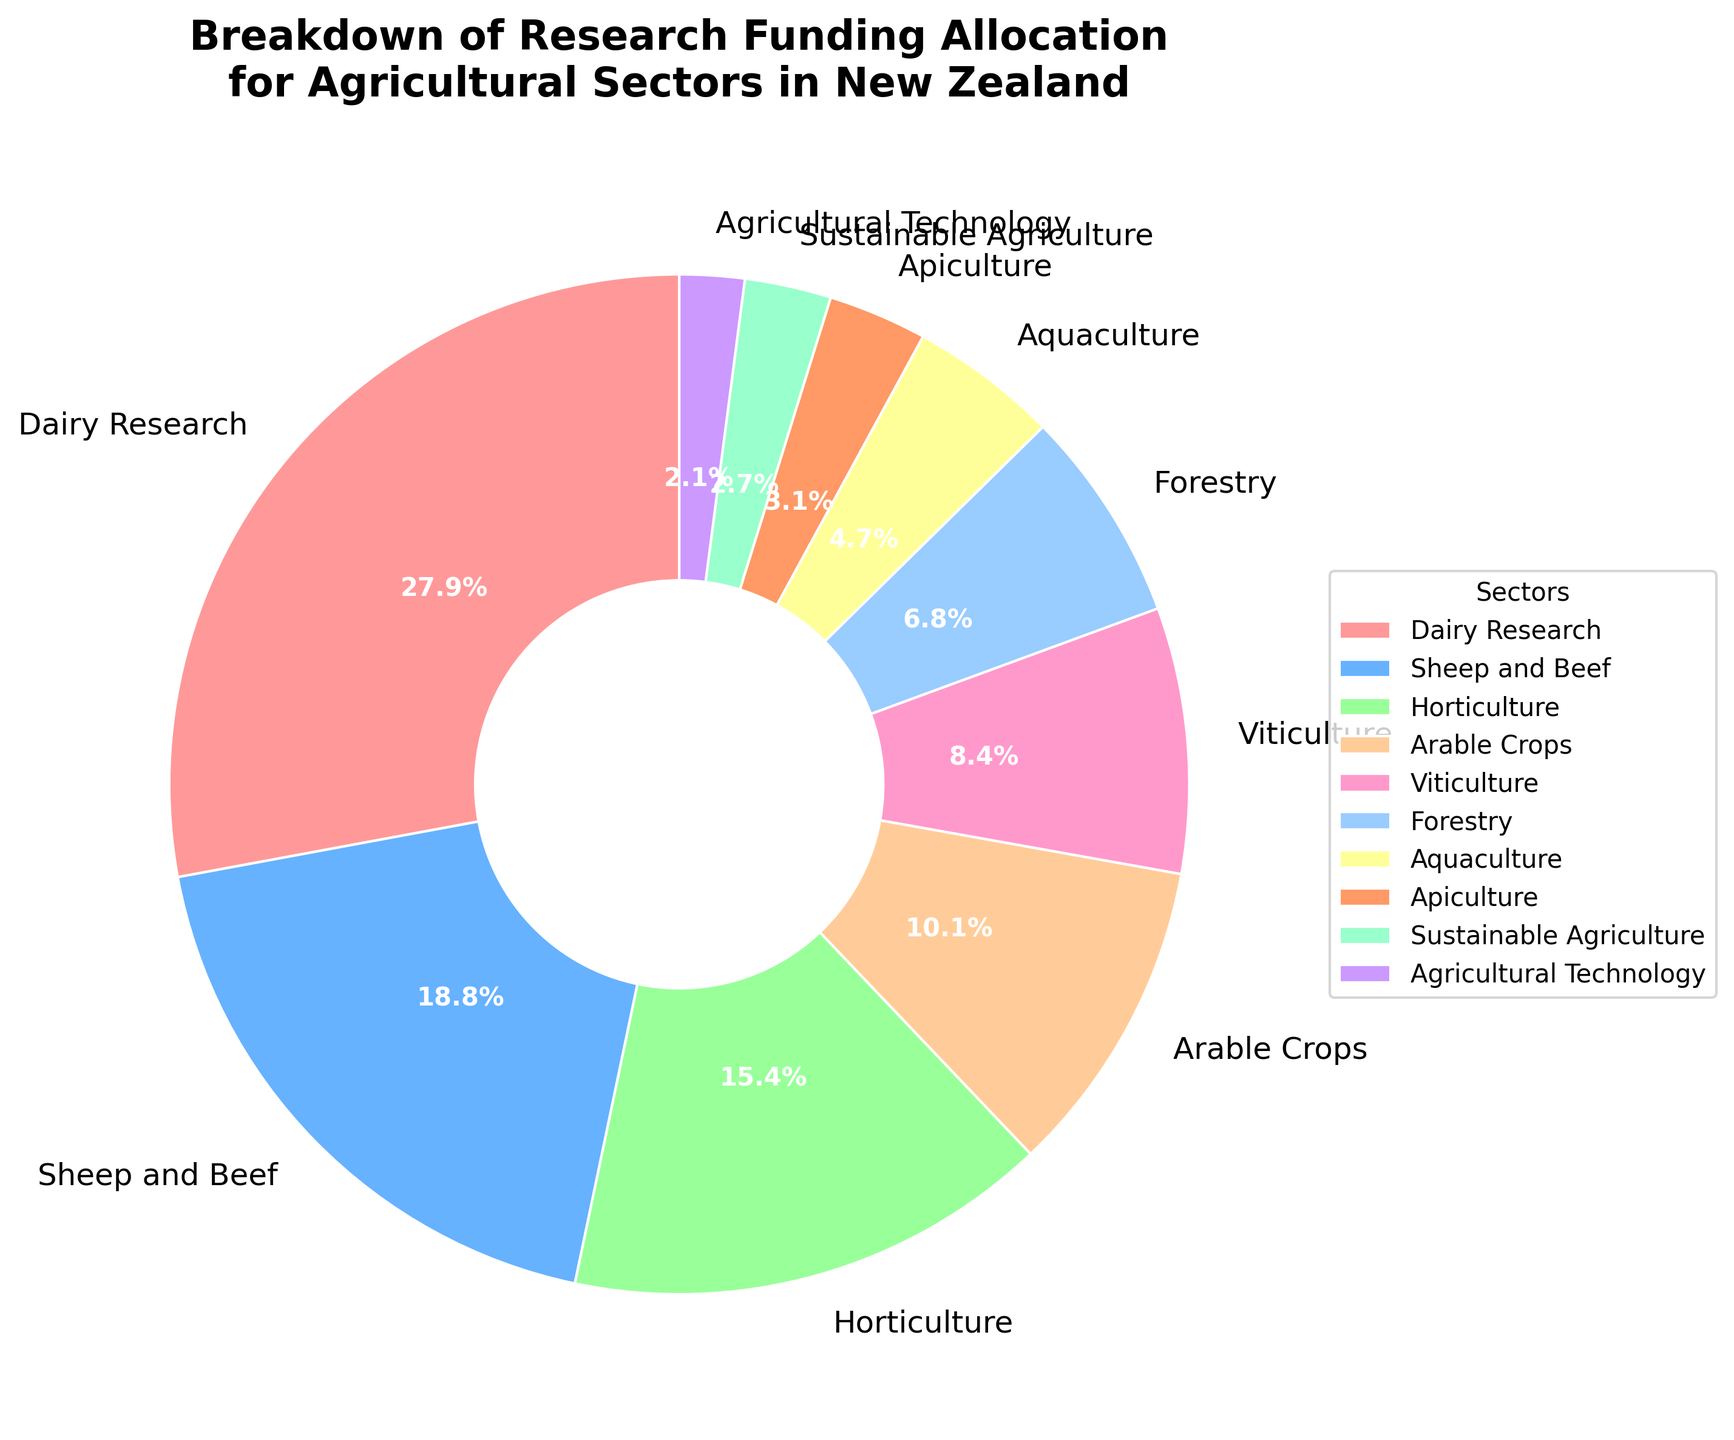What's the sector with the highest funding allocation? Looking at the pie chart, the sector with the largest slice of the pie chart represents the highest funding allocation. In this case, Dairy Research occupies the largest sector in the pie chart.
Answer: Dairy Research How much more funding percentage does Dairy Research receive compared to Arable Crops? According to the pie chart, Dairy Research receives 28.5% funding, and Arable Crops receives 10.3%. Subtracting these values gives the difference: 28.5% - 10.3% = 18.2%.
Answer: 18.2% Which sectors have funding allocations less than 5%? The pie chart segments that are less than 5% include Aquaculture, Apiculture, Sustainable Agriculture, and Agricultural Technology.
Answer: Aquaculture, Apiculture, Sustainable Agriculture, Agricultural Technology What is the combined funding percentage for Sheep and Beef, and Horticulture? The funding allocations for Sheep and Beef and Horticulture are 19.2% and 15.7%, respectively. Adding these together: 19.2% + 15.7% = 34.9%.
Answer: 34.9% What color represents the sector with the least funding allocation? Agricultural Technology has the smallest slice in the pie chart at 2.1%, which is represented by the color purple.
Answer: Purple What is the ratio of funding allocated to Forestry compared to Viticulture? From the pie chart, Forestry is allocated 6.9% and Viticulture 8.6%. To find the ratio, we divide the two values: 6.9% ÷ 8.6% ≈ 0.80, or approximately 4:5.
Answer: Approximately 4:5 Are there more sectors with funding allocation above or below 10%? According to the pie chart data, sectors above 10% include Dairy Research, Sheep and Beef, and Horticulture (3 sectors). Sectors below 10% are Arable Crops, Viticulture, Forestry, Aquaculture, Apiculture, Sustainable Agriculture, and Agricultural Technology (7 sectors). Thus, there are more sectors with below 10% allocation.
Answer: Below 10% Which three sectors together constitute approximately half of the total funding? To find three sectors that together make up about 50%, we look for the largest sectors. Dairy Research (28.5%), Sheep and Beef (19.2%), and Horticulture (15.7%) together make up: 28.5% + 19.2% + 15.7% = 63.4%, which is over half. Thus, removing Horticulture and adding another smaller one to meet approximately half, Dairy Research (28.5%) and Sheep and Beef (19.2%) alone sum up to 47.7%. Adding either Horticulture or a smaller percentage sector does not get close to exactly 50%. So it would be Dairy Research, Sheep and Beef making nearly half the allocation.
Answer: Dairy Research, Sheep and Beef How does funding for Viticulture compare with Apiculture? Viticulture at 8.6% is significantly larger than Apiculture at 3.2%. To see how much more, subtract Apiculture from Viticulture: 8.6% - 3.2% = 5.4%.
Answer: Viticulture has 5.4% more What is the average funding allocation for all sectors? To calculate the average, sum all the percentages and divide by the number of sectors. The sum is 28.5% + 19.2% + 15.7% + 10.3% + 8.6% + 6.9% + 4.8% + 3.2% + 2.8% + 2.1% = 102.1%. Dividing by 10 (the number of sectors) gives the average: 102.1% ÷ 10 = 10.21%.
Answer: 10.21% 